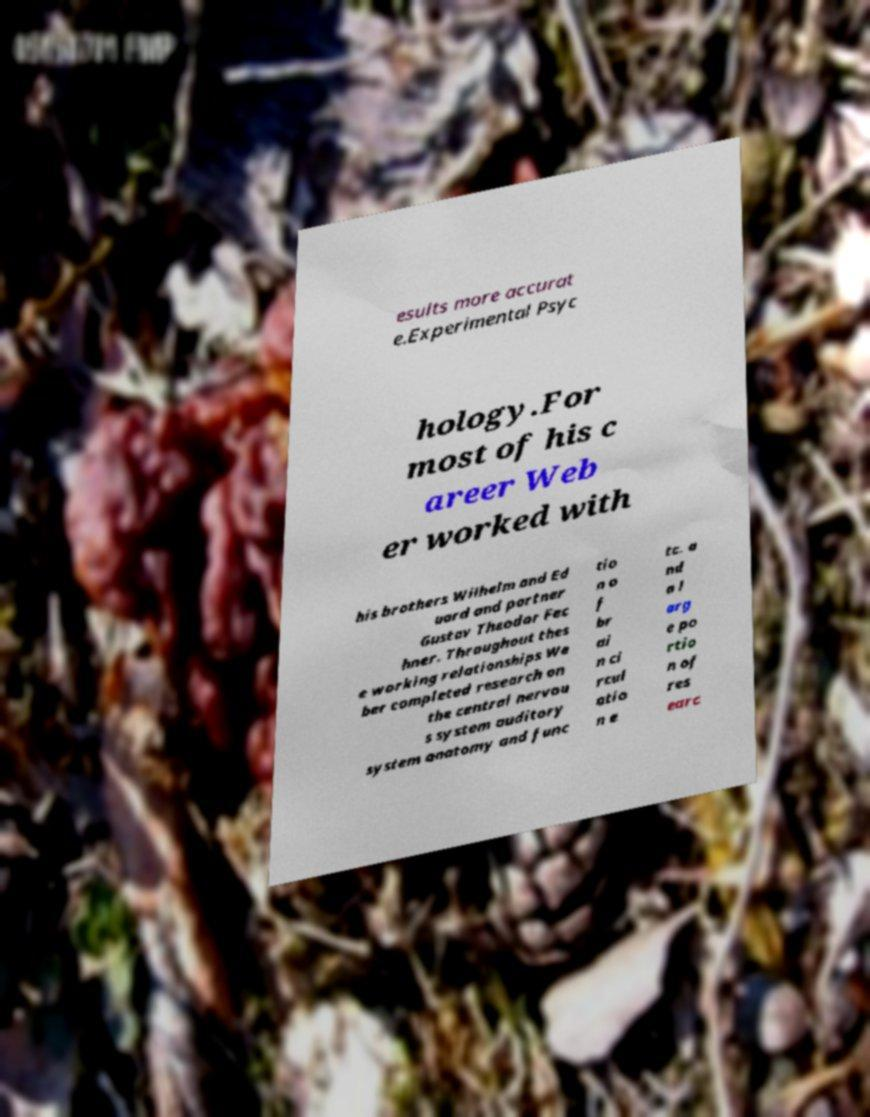Please read and relay the text visible in this image. What does it say? esults more accurat e.Experimental Psyc hology.For most of his c areer Web er worked with his brothers Wilhelm and Ed uard and partner Gustav Theodor Fec hner. Throughout thes e working relationships We ber completed research on the central nervou s system auditory system anatomy and func tio n o f br ai n ci rcul atio n e tc. a nd a l arg e po rtio n of res earc 